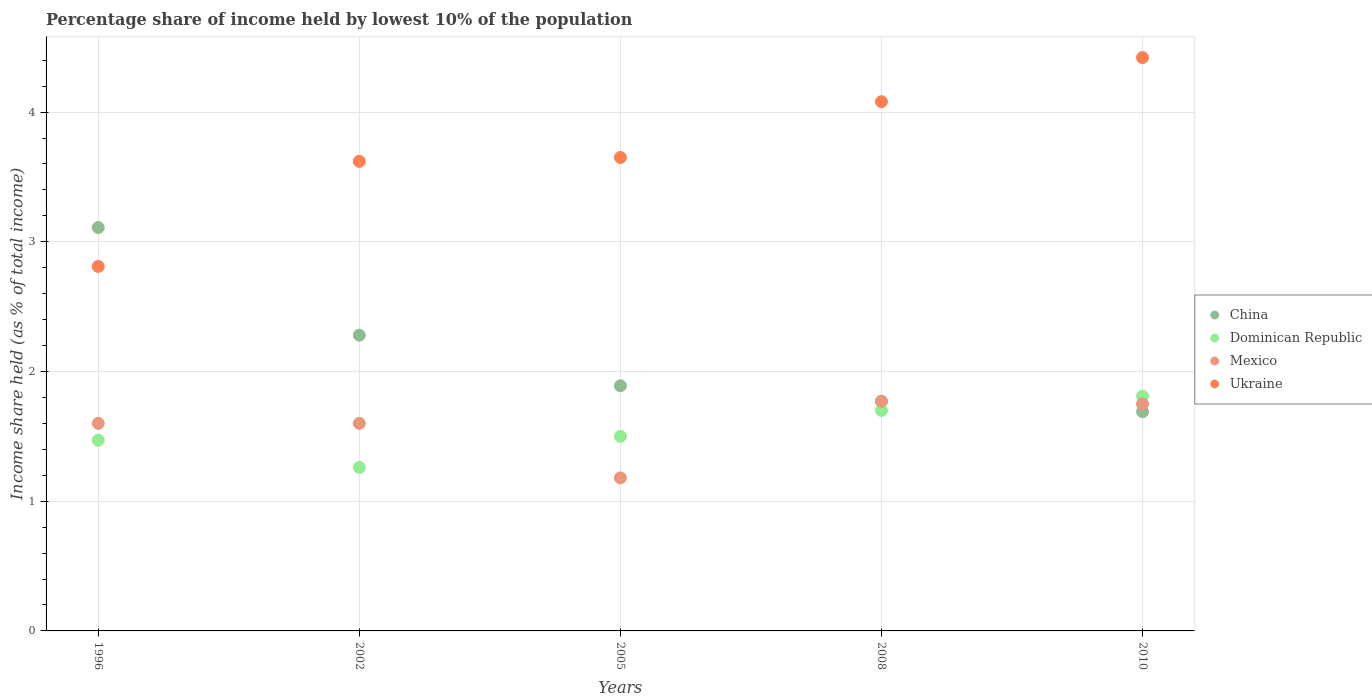How many different coloured dotlines are there?
Keep it short and to the point. 4. Is the number of dotlines equal to the number of legend labels?
Keep it short and to the point. Yes. Across all years, what is the maximum percentage share of income held by lowest 10% of the population in Dominican Republic?
Make the answer very short. 1.81. Across all years, what is the minimum percentage share of income held by lowest 10% of the population in Mexico?
Keep it short and to the point. 1.18. In which year was the percentage share of income held by lowest 10% of the population in Ukraine minimum?
Give a very brief answer. 1996. What is the total percentage share of income held by lowest 10% of the population in Mexico in the graph?
Offer a terse response. 7.9. What is the difference between the percentage share of income held by lowest 10% of the population in China in 2005 and that in 2010?
Provide a short and direct response. 0.2. What is the average percentage share of income held by lowest 10% of the population in Dominican Republic per year?
Your answer should be compact. 1.55. In the year 1996, what is the difference between the percentage share of income held by lowest 10% of the population in Mexico and percentage share of income held by lowest 10% of the population in Ukraine?
Your response must be concise. -1.21. What is the ratio of the percentage share of income held by lowest 10% of the population in Dominican Republic in 1996 to that in 2002?
Make the answer very short. 1.17. Is the difference between the percentage share of income held by lowest 10% of the population in Mexico in 1996 and 2005 greater than the difference between the percentage share of income held by lowest 10% of the population in Ukraine in 1996 and 2005?
Keep it short and to the point. Yes. What is the difference between the highest and the second highest percentage share of income held by lowest 10% of the population in Mexico?
Give a very brief answer. 0.02. What is the difference between the highest and the lowest percentage share of income held by lowest 10% of the population in China?
Provide a short and direct response. 1.42. Is the percentage share of income held by lowest 10% of the population in China strictly less than the percentage share of income held by lowest 10% of the population in Mexico over the years?
Keep it short and to the point. No. How many dotlines are there?
Your answer should be compact. 4. What is the difference between two consecutive major ticks on the Y-axis?
Make the answer very short. 1. Where does the legend appear in the graph?
Make the answer very short. Center right. What is the title of the graph?
Your answer should be compact. Percentage share of income held by lowest 10% of the population. What is the label or title of the X-axis?
Provide a succinct answer. Years. What is the label or title of the Y-axis?
Give a very brief answer. Income share held (as % of total income). What is the Income share held (as % of total income) in China in 1996?
Your response must be concise. 3.11. What is the Income share held (as % of total income) in Dominican Republic in 1996?
Provide a short and direct response. 1.47. What is the Income share held (as % of total income) of Ukraine in 1996?
Keep it short and to the point. 2.81. What is the Income share held (as % of total income) in China in 2002?
Keep it short and to the point. 2.28. What is the Income share held (as % of total income) in Dominican Republic in 2002?
Offer a very short reply. 1.26. What is the Income share held (as % of total income) in Mexico in 2002?
Provide a succinct answer. 1.6. What is the Income share held (as % of total income) in Ukraine in 2002?
Ensure brevity in your answer.  3.62. What is the Income share held (as % of total income) of China in 2005?
Ensure brevity in your answer.  1.89. What is the Income share held (as % of total income) of Mexico in 2005?
Offer a very short reply. 1.18. What is the Income share held (as % of total income) of Ukraine in 2005?
Make the answer very short. 3.65. What is the Income share held (as % of total income) in China in 2008?
Your answer should be compact. 1.77. What is the Income share held (as % of total income) in Mexico in 2008?
Your answer should be compact. 1.77. What is the Income share held (as % of total income) in Ukraine in 2008?
Offer a terse response. 4.08. What is the Income share held (as % of total income) in China in 2010?
Offer a very short reply. 1.69. What is the Income share held (as % of total income) in Dominican Republic in 2010?
Ensure brevity in your answer.  1.81. What is the Income share held (as % of total income) of Ukraine in 2010?
Give a very brief answer. 4.42. Across all years, what is the maximum Income share held (as % of total income) in China?
Offer a very short reply. 3.11. Across all years, what is the maximum Income share held (as % of total income) in Dominican Republic?
Your answer should be compact. 1.81. Across all years, what is the maximum Income share held (as % of total income) of Mexico?
Your answer should be very brief. 1.77. Across all years, what is the maximum Income share held (as % of total income) of Ukraine?
Offer a terse response. 4.42. Across all years, what is the minimum Income share held (as % of total income) of China?
Your answer should be compact. 1.69. Across all years, what is the minimum Income share held (as % of total income) of Dominican Republic?
Your answer should be very brief. 1.26. Across all years, what is the minimum Income share held (as % of total income) of Mexico?
Give a very brief answer. 1.18. Across all years, what is the minimum Income share held (as % of total income) in Ukraine?
Ensure brevity in your answer.  2.81. What is the total Income share held (as % of total income) in China in the graph?
Offer a very short reply. 10.74. What is the total Income share held (as % of total income) in Dominican Republic in the graph?
Your answer should be very brief. 7.74. What is the total Income share held (as % of total income) in Ukraine in the graph?
Your answer should be compact. 18.58. What is the difference between the Income share held (as % of total income) in China in 1996 and that in 2002?
Give a very brief answer. 0.83. What is the difference between the Income share held (as % of total income) in Dominican Republic in 1996 and that in 2002?
Your response must be concise. 0.21. What is the difference between the Income share held (as % of total income) of Ukraine in 1996 and that in 2002?
Offer a terse response. -0.81. What is the difference between the Income share held (as % of total income) in China in 1996 and that in 2005?
Your answer should be compact. 1.22. What is the difference between the Income share held (as % of total income) in Dominican Republic in 1996 and that in 2005?
Keep it short and to the point. -0.03. What is the difference between the Income share held (as % of total income) in Mexico in 1996 and that in 2005?
Keep it short and to the point. 0.42. What is the difference between the Income share held (as % of total income) in Ukraine in 1996 and that in 2005?
Your answer should be compact. -0.84. What is the difference between the Income share held (as % of total income) in China in 1996 and that in 2008?
Make the answer very short. 1.34. What is the difference between the Income share held (as % of total income) in Dominican Republic in 1996 and that in 2008?
Make the answer very short. -0.23. What is the difference between the Income share held (as % of total income) of Mexico in 1996 and that in 2008?
Your response must be concise. -0.17. What is the difference between the Income share held (as % of total income) in Ukraine in 1996 and that in 2008?
Your answer should be compact. -1.27. What is the difference between the Income share held (as % of total income) of China in 1996 and that in 2010?
Your response must be concise. 1.42. What is the difference between the Income share held (as % of total income) in Dominican Republic in 1996 and that in 2010?
Keep it short and to the point. -0.34. What is the difference between the Income share held (as % of total income) of Mexico in 1996 and that in 2010?
Offer a very short reply. -0.15. What is the difference between the Income share held (as % of total income) in Ukraine in 1996 and that in 2010?
Your response must be concise. -1.61. What is the difference between the Income share held (as % of total income) of China in 2002 and that in 2005?
Your answer should be very brief. 0.39. What is the difference between the Income share held (as % of total income) in Dominican Republic in 2002 and that in 2005?
Your answer should be compact. -0.24. What is the difference between the Income share held (as % of total income) of Mexico in 2002 and that in 2005?
Keep it short and to the point. 0.42. What is the difference between the Income share held (as % of total income) of Ukraine in 2002 and that in 2005?
Offer a very short reply. -0.03. What is the difference between the Income share held (as % of total income) in China in 2002 and that in 2008?
Your answer should be very brief. 0.51. What is the difference between the Income share held (as % of total income) in Dominican Republic in 2002 and that in 2008?
Your response must be concise. -0.44. What is the difference between the Income share held (as % of total income) in Mexico in 2002 and that in 2008?
Make the answer very short. -0.17. What is the difference between the Income share held (as % of total income) of Ukraine in 2002 and that in 2008?
Make the answer very short. -0.46. What is the difference between the Income share held (as % of total income) of China in 2002 and that in 2010?
Offer a terse response. 0.59. What is the difference between the Income share held (as % of total income) in Dominican Republic in 2002 and that in 2010?
Ensure brevity in your answer.  -0.55. What is the difference between the Income share held (as % of total income) in Mexico in 2002 and that in 2010?
Keep it short and to the point. -0.15. What is the difference between the Income share held (as % of total income) of Ukraine in 2002 and that in 2010?
Provide a short and direct response. -0.8. What is the difference between the Income share held (as % of total income) of China in 2005 and that in 2008?
Make the answer very short. 0.12. What is the difference between the Income share held (as % of total income) in Dominican Republic in 2005 and that in 2008?
Give a very brief answer. -0.2. What is the difference between the Income share held (as % of total income) of Mexico in 2005 and that in 2008?
Your response must be concise. -0.59. What is the difference between the Income share held (as % of total income) in Ukraine in 2005 and that in 2008?
Your answer should be compact. -0.43. What is the difference between the Income share held (as % of total income) in Dominican Republic in 2005 and that in 2010?
Give a very brief answer. -0.31. What is the difference between the Income share held (as % of total income) in Mexico in 2005 and that in 2010?
Your response must be concise. -0.57. What is the difference between the Income share held (as % of total income) of Ukraine in 2005 and that in 2010?
Your response must be concise. -0.77. What is the difference between the Income share held (as % of total income) of China in 2008 and that in 2010?
Provide a short and direct response. 0.08. What is the difference between the Income share held (as % of total income) in Dominican Republic in 2008 and that in 2010?
Give a very brief answer. -0.11. What is the difference between the Income share held (as % of total income) in Mexico in 2008 and that in 2010?
Your answer should be very brief. 0.02. What is the difference between the Income share held (as % of total income) of Ukraine in 2008 and that in 2010?
Offer a very short reply. -0.34. What is the difference between the Income share held (as % of total income) in China in 1996 and the Income share held (as % of total income) in Dominican Republic in 2002?
Offer a terse response. 1.85. What is the difference between the Income share held (as % of total income) in China in 1996 and the Income share held (as % of total income) in Mexico in 2002?
Ensure brevity in your answer.  1.51. What is the difference between the Income share held (as % of total income) in China in 1996 and the Income share held (as % of total income) in Ukraine in 2002?
Provide a succinct answer. -0.51. What is the difference between the Income share held (as % of total income) of Dominican Republic in 1996 and the Income share held (as % of total income) of Mexico in 2002?
Your response must be concise. -0.13. What is the difference between the Income share held (as % of total income) of Dominican Republic in 1996 and the Income share held (as % of total income) of Ukraine in 2002?
Keep it short and to the point. -2.15. What is the difference between the Income share held (as % of total income) of Mexico in 1996 and the Income share held (as % of total income) of Ukraine in 2002?
Provide a short and direct response. -2.02. What is the difference between the Income share held (as % of total income) in China in 1996 and the Income share held (as % of total income) in Dominican Republic in 2005?
Your answer should be very brief. 1.61. What is the difference between the Income share held (as % of total income) of China in 1996 and the Income share held (as % of total income) of Mexico in 2005?
Your answer should be very brief. 1.93. What is the difference between the Income share held (as % of total income) in China in 1996 and the Income share held (as % of total income) in Ukraine in 2005?
Provide a short and direct response. -0.54. What is the difference between the Income share held (as % of total income) in Dominican Republic in 1996 and the Income share held (as % of total income) in Mexico in 2005?
Provide a succinct answer. 0.29. What is the difference between the Income share held (as % of total income) of Dominican Republic in 1996 and the Income share held (as % of total income) of Ukraine in 2005?
Offer a very short reply. -2.18. What is the difference between the Income share held (as % of total income) of Mexico in 1996 and the Income share held (as % of total income) of Ukraine in 2005?
Give a very brief answer. -2.05. What is the difference between the Income share held (as % of total income) of China in 1996 and the Income share held (as % of total income) of Dominican Republic in 2008?
Your response must be concise. 1.41. What is the difference between the Income share held (as % of total income) of China in 1996 and the Income share held (as % of total income) of Mexico in 2008?
Ensure brevity in your answer.  1.34. What is the difference between the Income share held (as % of total income) in China in 1996 and the Income share held (as % of total income) in Ukraine in 2008?
Provide a short and direct response. -0.97. What is the difference between the Income share held (as % of total income) of Dominican Republic in 1996 and the Income share held (as % of total income) of Mexico in 2008?
Provide a succinct answer. -0.3. What is the difference between the Income share held (as % of total income) in Dominican Republic in 1996 and the Income share held (as % of total income) in Ukraine in 2008?
Keep it short and to the point. -2.61. What is the difference between the Income share held (as % of total income) in Mexico in 1996 and the Income share held (as % of total income) in Ukraine in 2008?
Provide a succinct answer. -2.48. What is the difference between the Income share held (as % of total income) of China in 1996 and the Income share held (as % of total income) of Dominican Republic in 2010?
Provide a succinct answer. 1.3. What is the difference between the Income share held (as % of total income) in China in 1996 and the Income share held (as % of total income) in Mexico in 2010?
Make the answer very short. 1.36. What is the difference between the Income share held (as % of total income) of China in 1996 and the Income share held (as % of total income) of Ukraine in 2010?
Give a very brief answer. -1.31. What is the difference between the Income share held (as % of total income) in Dominican Republic in 1996 and the Income share held (as % of total income) in Mexico in 2010?
Your answer should be very brief. -0.28. What is the difference between the Income share held (as % of total income) of Dominican Republic in 1996 and the Income share held (as % of total income) of Ukraine in 2010?
Offer a very short reply. -2.95. What is the difference between the Income share held (as % of total income) in Mexico in 1996 and the Income share held (as % of total income) in Ukraine in 2010?
Provide a short and direct response. -2.82. What is the difference between the Income share held (as % of total income) of China in 2002 and the Income share held (as % of total income) of Dominican Republic in 2005?
Keep it short and to the point. 0.78. What is the difference between the Income share held (as % of total income) of China in 2002 and the Income share held (as % of total income) of Ukraine in 2005?
Your response must be concise. -1.37. What is the difference between the Income share held (as % of total income) of Dominican Republic in 2002 and the Income share held (as % of total income) of Mexico in 2005?
Make the answer very short. 0.08. What is the difference between the Income share held (as % of total income) of Dominican Republic in 2002 and the Income share held (as % of total income) of Ukraine in 2005?
Provide a short and direct response. -2.39. What is the difference between the Income share held (as % of total income) in Mexico in 2002 and the Income share held (as % of total income) in Ukraine in 2005?
Provide a succinct answer. -2.05. What is the difference between the Income share held (as % of total income) of China in 2002 and the Income share held (as % of total income) of Dominican Republic in 2008?
Your answer should be compact. 0.58. What is the difference between the Income share held (as % of total income) of China in 2002 and the Income share held (as % of total income) of Mexico in 2008?
Give a very brief answer. 0.51. What is the difference between the Income share held (as % of total income) in Dominican Republic in 2002 and the Income share held (as % of total income) in Mexico in 2008?
Offer a terse response. -0.51. What is the difference between the Income share held (as % of total income) in Dominican Republic in 2002 and the Income share held (as % of total income) in Ukraine in 2008?
Your answer should be very brief. -2.82. What is the difference between the Income share held (as % of total income) of Mexico in 2002 and the Income share held (as % of total income) of Ukraine in 2008?
Ensure brevity in your answer.  -2.48. What is the difference between the Income share held (as % of total income) of China in 2002 and the Income share held (as % of total income) of Dominican Republic in 2010?
Offer a very short reply. 0.47. What is the difference between the Income share held (as % of total income) in China in 2002 and the Income share held (as % of total income) in Mexico in 2010?
Provide a succinct answer. 0.53. What is the difference between the Income share held (as % of total income) in China in 2002 and the Income share held (as % of total income) in Ukraine in 2010?
Provide a short and direct response. -2.14. What is the difference between the Income share held (as % of total income) in Dominican Republic in 2002 and the Income share held (as % of total income) in Mexico in 2010?
Provide a succinct answer. -0.49. What is the difference between the Income share held (as % of total income) in Dominican Republic in 2002 and the Income share held (as % of total income) in Ukraine in 2010?
Make the answer very short. -3.16. What is the difference between the Income share held (as % of total income) of Mexico in 2002 and the Income share held (as % of total income) of Ukraine in 2010?
Offer a very short reply. -2.82. What is the difference between the Income share held (as % of total income) of China in 2005 and the Income share held (as % of total income) of Dominican Republic in 2008?
Provide a short and direct response. 0.19. What is the difference between the Income share held (as % of total income) in China in 2005 and the Income share held (as % of total income) in Mexico in 2008?
Your response must be concise. 0.12. What is the difference between the Income share held (as % of total income) of China in 2005 and the Income share held (as % of total income) of Ukraine in 2008?
Offer a terse response. -2.19. What is the difference between the Income share held (as % of total income) of Dominican Republic in 2005 and the Income share held (as % of total income) of Mexico in 2008?
Provide a short and direct response. -0.27. What is the difference between the Income share held (as % of total income) in Dominican Republic in 2005 and the Income share held (as % of total income) in Ukraine in 2008?
Keep it short and to the point. -2.58. What is the difference between the Income share held (as % of total income) in Mexico in 2005 and the Income share held (as % of total income) in Ukraine in 2008?
Your response must be concise. -2.9. What is the difference between the Income share held (as % of total income) in China in 2005 and the Income share held (as % of total income) in Mexico in 2010?
Your answer should be very brief. 0.14. What is the difference between the Income share held (as % of total income) of China in 2005 and the Income share held (as % of total income) of Ukraine in 2010?
Your response must be concise. -2.53. What is the difference between the Income share held (as % of total income) of Dominican Republic in 2005 and the Income share held (as % of total income) of Ukraine in 2010?
Provide a short and direct response. -2.92. What is the difference between the Income share held (as % of total income) of Mexico in 2005 and the Income share held (as % of total income) of Ukraine in 2010?
Your response must be concise. -3.24. What is the difference between the Income share held (as % of total income) of China in 2008 and the Income share held (as % of total income) of Dominican Republic in 2010?
Your answer should be very brief. -0.04. What is the difference between the Income share held (as % of total income) in China in 2008 and the Income share held (as % of total income) in Ukraine in 2010?
Keep it short and to the point. -2.65. What is the difference between the Income share held (as % of total income) in Dominican Republic in 2008 and the Income share held (as % of total income) in Ukraine in 2010?
Provide a short and direct response. -2.72. What is the difference between the Income share held (as % of total income) in Mexico in 2008 and the Income share held (as % of total income) in Ukraine in 2010?
Offer a terse response. -2.65. What is the average Income share held (as % of total income) of China per year?
Ensure brevity in your answer.  2.15. What is the average Income share held (as % of total income) of Dominican Republic per year?
Your response must be concise. 1.55. What is the average Income share held (as % of total income) in Mexico per year?
Your response must be concise. 1.58. What is the average Income share held (as % of total income) in Ukraine per year?
Your answer should be compact. 3.72. In the year 1996, what is the difference between the Income share held (as % of total income) of China and Income share held (as % of total income) of Dominican Republic?
Your response must be concise. 1.64. In the year 1996, what is the difference between the Income share held (as % of total income) of China and Income share held (as % of total income) of Mexico?
Give a very brief answer. 1.51. In the year 1996, what is the difference between the Income share held (as % of total income) of Dominican Republic and Income share held (as % of total income) of Mexico?
Provide a short and direct response. -0.13. In the year 1996, what is the difference between the Income share held (as % of total income) of Dominican Republic and Income share held (as % of total income) of Ukraine?
Provide a succinct answer. -1.34. In the year 1996, what is the difference between the Income share held (as % of total income) in Mexico and Income share held (as % of total income) in Ukraine?
Give a very brief answer. -1.21. In the year 2002, what is the difference between the Income share held (as % of total income) in China and Income share held (as % of total income) in Dominican Republic?
Your response must be concise. 1.02. In the year 2002, what is the difference between the Income share held (as % of total income) in China and Income share held (as % of total income) in Mexico?
Provide a short and direct response. 0.68. In the year 2002, what is the difference between the Income share held (as % of total income) of China and Income share held (as % of total income) of Ukraine?
Keep it short and to the point. -1.34. In the year 2002, what is the difference between the Income share held (as % of total income) in Dominican Republic and Income share held (as % of total income) in Mexico?
Offer a very short reply. -0.34. In the year 2002, what is the difference between the Income share held (as % of total income) of Dominican Republic and Income share held (as % of total income) of Ukraine?
Give a very brief answer. -2.36. In the year 2002, what is the difference between the Income share held (as % of total income) in Mexico and Income share held (as % of total income) in Ukraine?
Make the answer very short. -2.02. In the year 2005, what is the difference between the Income share held (as % of total income) of China and Income share held (as % of total income) of Dominican Republic?
Your response must be concise. 0.39. In the year 2005, what is the difference between the Income share held (as % of total income) of China and Income share held (as % of total income) of Mexico?
Offer a terse response. 0.71. In the year 2005, what is the difference between the Income share held (as % of total income) of China and Income share held (as % of total income) of Ukraine?
Give a very brief answer. -1.76. In the year 2005, what is the difference between the Income share held (as % of total income) in Dominican Republic and Income share held (as % of total income) in Mexico?
Offer a terse response. 0.32. In the year 2005, what is the difference between the Income share held (as % of total income) in Dominican Republic and Income share held (as % of total income) in Ukraine?
Offer a very short reply. -2.15. In the year 2005, what is the difference between the Income share held (as % of total income) of Mexico and Income share held (as % of total income) of Ukraine?
Offer a very short reply. -2.47. In the year 2008, what is the difference between the Income share held (as % of total income) in China and Income share held (as % of total income) in Dominican Republic?
Your answer should be compact. 0.07. In the year 2008, what is the difference between the Income share held (as % of total income) of China and Income share held (as % of total income) of Ukraine?
Give a very brief answer. -2.31. In the year 2008, what is the difference between the Income share held (as % of total income) of Dominican Republic and Income share held (as % of total income) of Mexico?
Offer a terse response. -0.07. In the year 2008, what is the difference between the Income share held (as % of total income) in Dominican Republic and Income share held (as % of total income) in Ukraine?
Your answer should be compact. -2.38. In the year 2008, what is the difference between the Income share held (as % of total income) of Mexico and Income share held (as % of total income) of Ukraine?
Ensure brevity in your answer.  -2.31. In the year 2010, what is the difference between the Income share held (as % of total income) of China and Income share held (as % of total income) of Dominican Republic?
Your answer should be very brief. -0.12. In the year 2010, what is the difference between the Income share held (as % of total income) of China and Income share held (as % of total income) of Mexico?
Provide a succinct answer. -0.06. In the year 2010, what is the difference between the Income share held (as % of total income) in China and Income share held (as % of total income) in Ukraine?
Make the answer very short. -2.73. In the year 2010, what is the difference between the Income share held (as % of total income) of Dominican Republic and Income share held (as % of total income) of Mexico?
Your answer should be compact. 0.06. In the year 2010, what is the difference between the Income share held (as % of total income) in Dominican Republic and Income share held (as % of total income) in Ukraine?
Your answer should be compact. -2.61. In the year 2010, what is the difference between the Income share held (as % of total income) of Mexico and Income share held (as % of total income) of Ukraine?
Provide a succinct answer. -2.67. What is the ratio of the Income share held (as % of total income) in China in 1996 to that in 2002?
Your response must be concise. 1.36. What is the ratio of the Income share held (as % of total income) of Dominican Republic in 1996 to that in 2002?
Your answer should be very brief. 1.17. What is the ratio of the Income share held (as % of total income) in Mexico in 1996 to that in 2002?
Provide a succinct answer. 1. What is the ratio of the Income share held (as % of total income) of Ukraine in 1996 to that in 2002?
Your response must be concise. 0.78. What is the ratio of the Income share held (as % of total income) of China in 1996 to that in 2005?
Give a very brief answer. 1.65. What is the ratio of the Income share held (as % of total income) in Mexico in 1996 to that in 2005?
Give a very brief answer. 1.36. What is the ratio of the Income share held (as % of total income) of Ukraine in 1996 to that in 2005?
Give a very brief answer. 0.77. What is the ratio of the Income share held (as % of total income) in China in 1996 to that in 2008?
Your answer should be compact. 1.76. What is the ratio of the Income share held (as % of total income) in Dominican Republic in 1996 to that in 2008?
Ensure brevity in your answer.  0.86. What is the ratio of the Income share held (as % of total income) of Mexico in 1996 to that in 2008?
Your answer should be very brief. 0.9. What is the ratio of the Income share held (as % of total income) of Ukraine in 1996 to that in 2008?
Keep it short and to the point. 0.69. What is the ratio of the Income share held (as % of total income) of China in 1996 to that in 2010?
Offer a very short reply. 1.84. What is the ratio of the Income share held (as % of total income) of Dominican Republic in 1996 to that in 2010?
Ensure brevity in your answer.  0.81. What is the ratio of the Income share held (as % of total income) in Mexico in 1996 to that in 2010?
Your response must be concise. 0.91. What is the ratio of the Income share held (as % of total income) of Ukraine in 1996 to that in 2010?
Offer a very short reply. 0.64. What is the ratio of the Income share held (as % of total income) in China in 2002 to that in 2005?
Provide a short and direct response. 1.21. What is the ratio of the Income share held (as % of total income) in Dominican Republic in 2002 to that in 2005?
Your response must be concise. 0.84. What is the ratio of the Income share held (as % of total income) in Mexico in 2002 to that in 2005?
Provide a succinct answer. 1.36. What is the ratio of the Income share held (as % of total income) of Ukraine in 2002 to that in 2005?
Your answer should be very brief. 0.99. What is the ratio of the Income share held (as % of total income) of China in 2002 to that in 2008?
Your answer should be compact. 1.29. What is the ratio of the Income share held (as % of total income) of Dominican Republic in 2002 to that in 2008?
Your response must be concise. 0.74. What is the ratio of the Income share held (as % of total income) in Mexico in 2002 to that in 2008?
Offer a very short reply. 0.9. What is the ratio of the Income share held (as % of total income) of Ukraine in 2002 to that in 2008?
Your answer should be very brief. 0.89. What is the ratio of the Income share held (as % of total income) of China in 2002 to that in 2010?
Provide a short and direct response. 1.35. What is the ratio of the Income share held (as % of total income) of Dominican Republic in 2002 to that in 2010?
Ensure brevity in your answer.  0.7. What is the ratio of the Income share held (as % of total income) of Mexico in 2002 to that in 2010?
Keep it short and to the point. 0.91. What is the ratio of the Income share held (as % of total income) of Ukraine in 2002 to that in 2010?
Keep it short and to the point. 0.82. What is the ratio of the Income share held (as % of total income) in China in 2005 to that in 2008?
Keep it short and to the point. 1.07. What is the ratio of the Income share held (as % of total income) in Dominican Republic in 2005 to that in 2008?
Provide a succinct answer. 0.88. What is the ratio of the Income share held (as % of total income) in Ukraine in 2005 to that in 2008?
Make the answer very short. 0.89. What is the ratio of the Income share held (as % of total income) in China in 2005 to that in 2010?
Make the answer very short. 1.12. What is the ratio of the Income share held (as % of total income) in Dominican Republic in 2005 to that in 2010?
Ensure brevity in your answer.  0.83. What is the ratio of the Income share held (as % of total income) in Mexico in 2005 to that in 2010?
Offer a very short reply. 0.67. What is the ratio of the Income share held (as % of total income) of Ukraine in 2005 to that in 2010?
Ensure brevity in your answer.  0.83. What is the ratio of the Income share held (as % of total income) of China in 2008 to that in 2010?
Your answer should be compact. 1.05. What is the ratio of the Income share held (as % of total income) of Dominican Republic in 2008 to that in 2010?
Keep it short and to the point. 0.94. What is the ratio of the Income share held (as % of total income) of Mexico in 2008 to that in 2010?
Your answer should be very brief. 1.01. What is the ratio of the Income share held (as % of total income) in Ukraine in 2008 to that in 2010?
Offer a very short reply. 0.92. What is the difference between the highest and the second highest Income share held (as % of total income) of China?
Your answer should be compact. 0.83. What is the difference between the highest and the second highest Income share held (as % of total income) of Dominican Republic?
Ensure brevity in your answer.  0.11. What is the difference between the highest and the second highest Income share held (as % of total income) of Ukraine?
Your answer should be compact. 0.34. What is the difference between the highest and the lowest Income share held (as % of total income) of China?
Ensure brevity in your answer.  1.42. What is the difference between the highest and the lowest Income share held (as % of total income) of Dominican Republic?
Offer a very short reply. 0.55. What is the difference between the highest and the lowest Income share held (as % of total income) of Mexico?
Offer a very short reply. 0.59. What is the difference between the highest and the lowest Income share held (as % of total income) of Ukraine?
Your answer should be compact. 1.61. 